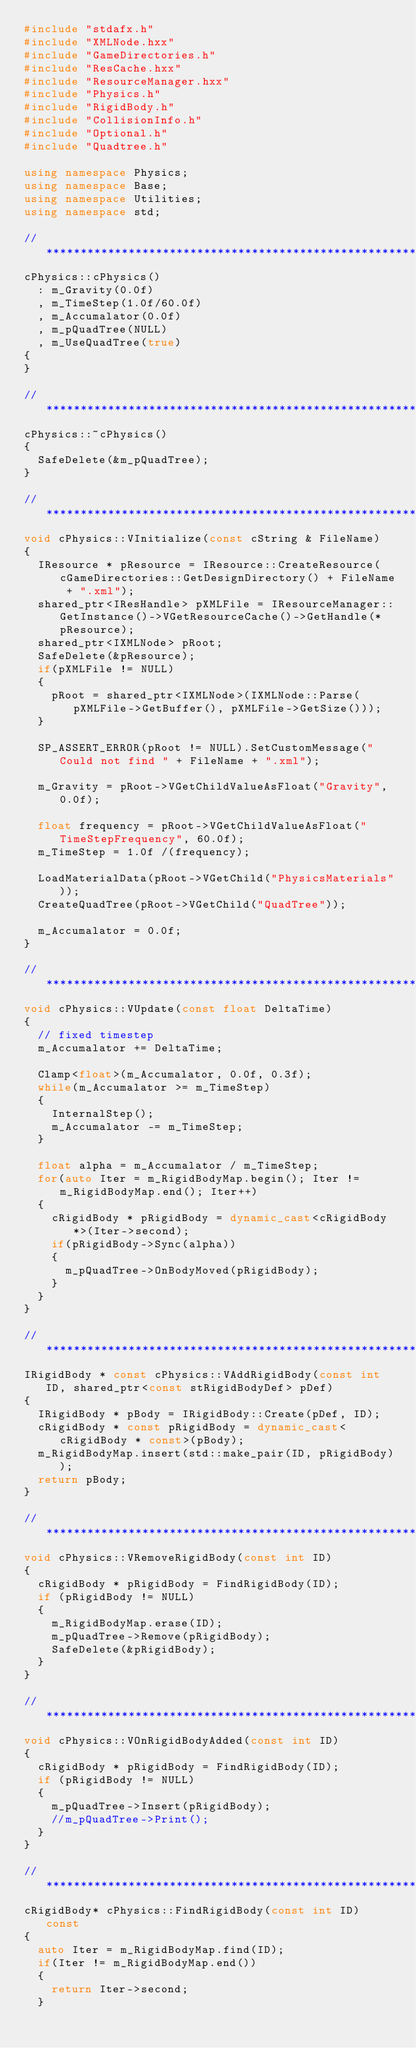<code> <loc_0><loc_0><loc_500><loc_500><_C++_>#include "stdafx.h"
#include "XMLNode.hxx"
#include "GameDirectories.h"
#include "ResCache.hxx"
#include "ResourceManager.hxx"
#include "Physics.h"
#include "RigidBody.h"
#include "CollisionInfo.h"
#include "Optional.h"
#include "Quadtree.h"

using namespace Physics;
using namespace Base;
using namespace Utilities;
using namespace std;

//  *******************************************************************************************************************
cPhysics::cPhysics()
	: m_Gravity(0.0f)
	, m_TimeStep(1.0f/60.0f)
	, m_Accumalator(0.0f)
	, m_pQuadTree(NULL)
	, m_UseQuadTree(true)
{
}

//  *******************************************************************************************************************
cPhysics::~cPhysics()
{
	SafeDelete(&m_pQuadTree);
}

//  *******************************************************************************************************************
void cPhysics::VInitialize(const cString & FileName)
{
	IResource * pResource = IResource::CreateResource(cGameDirectories::GetDesignDirectory() + FileName + ".xml");
	shared_ptr<IResHandle> pXMLFile = IResourceManager::GetInstance()->VGetResourceCache()->GetHandle(*pResource);
	shared_ptr<IXMLNode> pRoot;
	SafeDelete(&pResource);
	if(pXMLFile != NULL)
	{
		pRoot = shared_ptr<IXMLNode>(IXMLNode::Parse(pXMLFile->GetBuffer(), pXMLFile->GetSize()));
	}

	SP_ASSERT_ERROR(pRoot != NULL).SetCustomMessage("Could not find " + FileName + ".xml");

	m_Gravity = pRoot->VGetChildValueAsFloat("Gravity", 0.0f);

	float frequency = pRoot->VGetChildValueAsFloat("TimeStepFrequency", 60.0f);
	m_TimeStep = 1.0f /(frequency);

	LoadMaterialData(pRoot->VGetChild("PhysicsMaterials"));
	CreateQuadTree(pRoot->VGetChild("QuadTree"));

	m_Accumalator = 0.0f;
}

//  *******************************************************************************************************************
void cPhysics::VUpdate(const float DeltaTime)
{
	// fixed timestep
	m_Accumalator += DeltaTime;

	Clamp<float>(m_Accumalator, 0.0f, 0.3f);
	while(m_Accumalator >= m_TimeStep)
	{
		InternalStep();
		m_Accumalator -= m_TimeStep;
	}

	float alpha = m_Accumalator / m_TimeStep;
	for(auto Iter = m_RigidBodyMap.begin(); Iter != m_RigidBodyMap.end(); Iter++)
	{
		cRigidBody * pRigidBody = dynamic_cast<cRigidBody*>(Iter->second);
		if(pRigidBody->Sync(alpha))
		{
			m_pQuadTree->OnBodyMoved(pRigidBody);
		}
	}
}

//  *******************************************************************************************************************
IRigidBody * const cPhysics::VAddRigidBody(const int ID, shared_ptr<const stRigidBodyDef> pDef)
{
	IRigidBody * pBody = IRigidBody::Create(pDef, ID);
	cRigidBody * const pRigidBody = dynamic_cast<cRigidBody * const>(pBody);
	m_RigidBodyMap.insert(std::make_pair(ID, pRigidBody));
	return pBody;
}

//  *******************************************************************************************************************
void cPhysics::VRemoveRigidBody(const int ID)
{
	cRigidBody * pRigidBody = FindRigidBody(ID);
	if (pRigidBody != NULL)
	{
		m_RigidBodyMap.erase(ID);
		m_pQuadTree->Remove(pRigidBody);
		SafeDelete(&pRigidBody);
	}
}

//  *******************************************************************************************************************
void cPhysics::VOnRigidBodyAdded(const int ID)
{
	cRigidBody * pRigidBody = FindRigidBody(ID);
	if (pRigidBody != NULL)
	{
		m_pQuadTree->Insert(pRigidBody);
		//m_pQuadTree->Print();
	}
}

//  *******************************************************************************************************************
cRigidBody* cPhysics::FindRigidBody(const int ID) const
{
	auto Iter = m_RigidBodyMap.find(ID);
	if(Iter != m_RigidBodyMap.end())
	{
		return Iter->second;
	}
</code> 